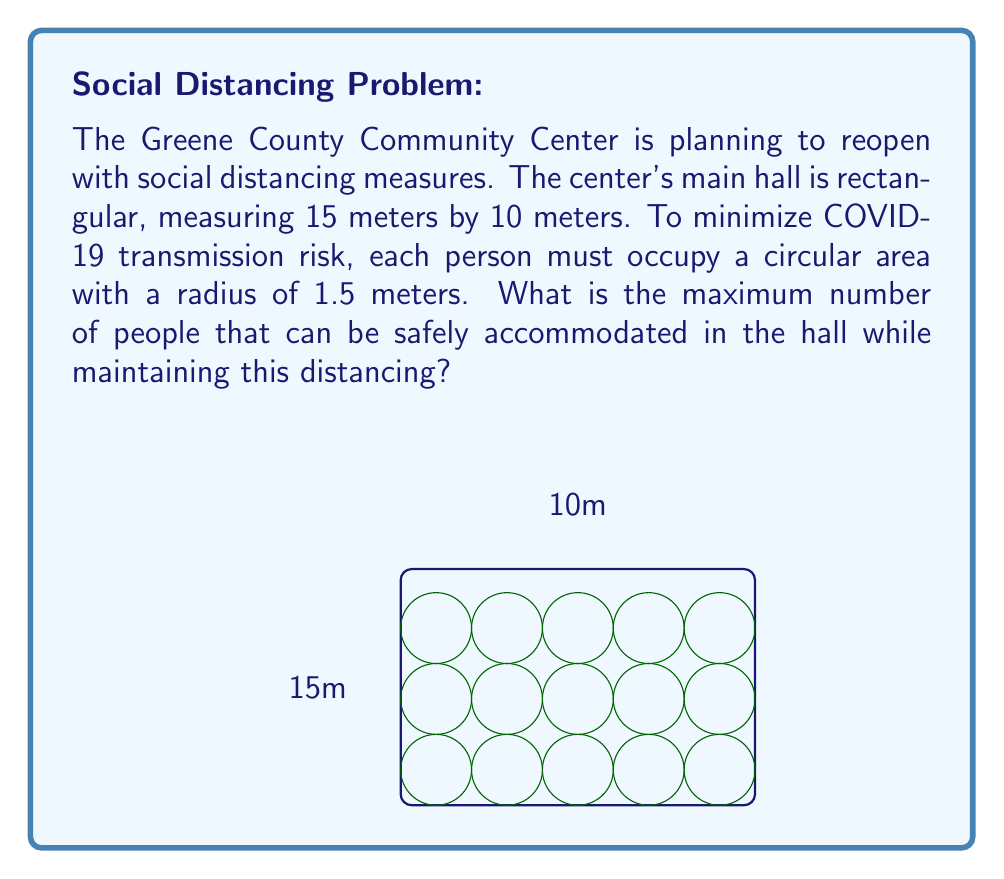Could you help me with this problem? Let's approach this step-by-step:

1) Each person occupies a circular area with a radius of 1.5 meters. This means the diameter of each person's space is 3 meters.

2) To maximize capacity, we need to arrange these circles in a grid pattern. The centers of the circles will form a grid with 3-meter spacing.

3) In the 15-meter length:
   $\text{Number of people along length} = \lfloor\frac{15}{3}\rfloor = 5$
   We use the floor function because we can't have partial people.

4) In the 10-meter width:
   $\text{Number of people along width} = \lfloor\frac{10}{3}\rfloor = 3$

5) The total number of people is the product of these two numbers:
   $\text{Total people} = 5 \times 3 = 15$

6) We can verify that this arrangement fits:
   Length occupied: $5 \times 3 = 15$ meters (exactly fits)
   Width occupied: $3 \times 3 = 9$ meters (leaves 1 meter extra)

This arrangement maximizes capacity while ensuring each person has a 3-meter diameter circular space, thus minimizing infection risk.
Answer: 15 people 